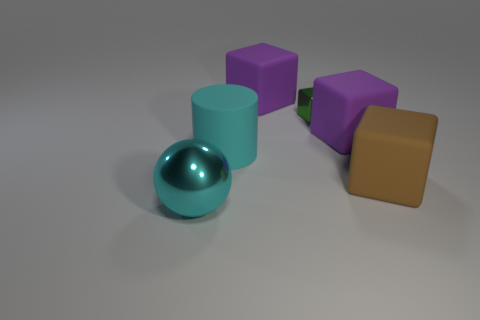Are there any big things that are behind the purple thing that is on the left side of the tiny green object that is behind the cyan metal ball?
Give a very brief answer. No. Is there anything else that has the same shape as the big cyan metallic thing?
Give a very brief answer. No. There is a object that is on the left side of the big cyan matte thing; does it have the same color as the big cylinder left of the small metal block?
Your answer should be very brief. Yes. Is there a green object?
Offer a very short reply. Yes. There is a cylinder that is the same color as the ball; what is it made of?
Provide a succinct answer. Rubber. There is a shiny thing that is to the right of the thing that is to the left of the big cyan thing that is behind the brown rubber thing; what is its size?
Your response must be concise. Small. Does the big brown rubber object have the same shape as the metallic object in front of the small cube?
Provide a succinct answer. No. Is there a big rubber cylinder of the same color as the large ball?
Offer a very short reply. Yes. What number of balls are small brown things or large cyan things?
Your answer should be compact. 1. Are there any big brown things that have the same shape as the tiny metallic thing?
Provide a succinct answer. Yes. 